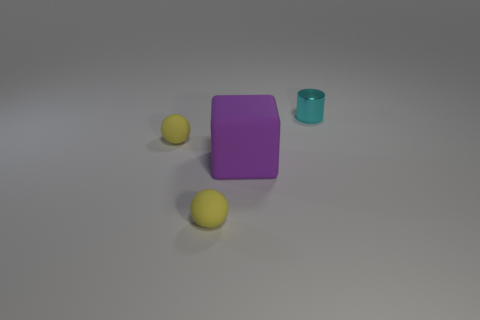Add 4 tiny yellow spheres. How many objects exist? 8 Subtract all blocks. How many objects are left? 3 Add 4 purple things. How many purple things are left? 5 Add 3 big purple blocks. How many big purple blocks exist? 4 Subtract 0 purple cylinders. How many objects are left? 4 Subtract all matte balls. Subtract all spheres. How many objects are left? 0 